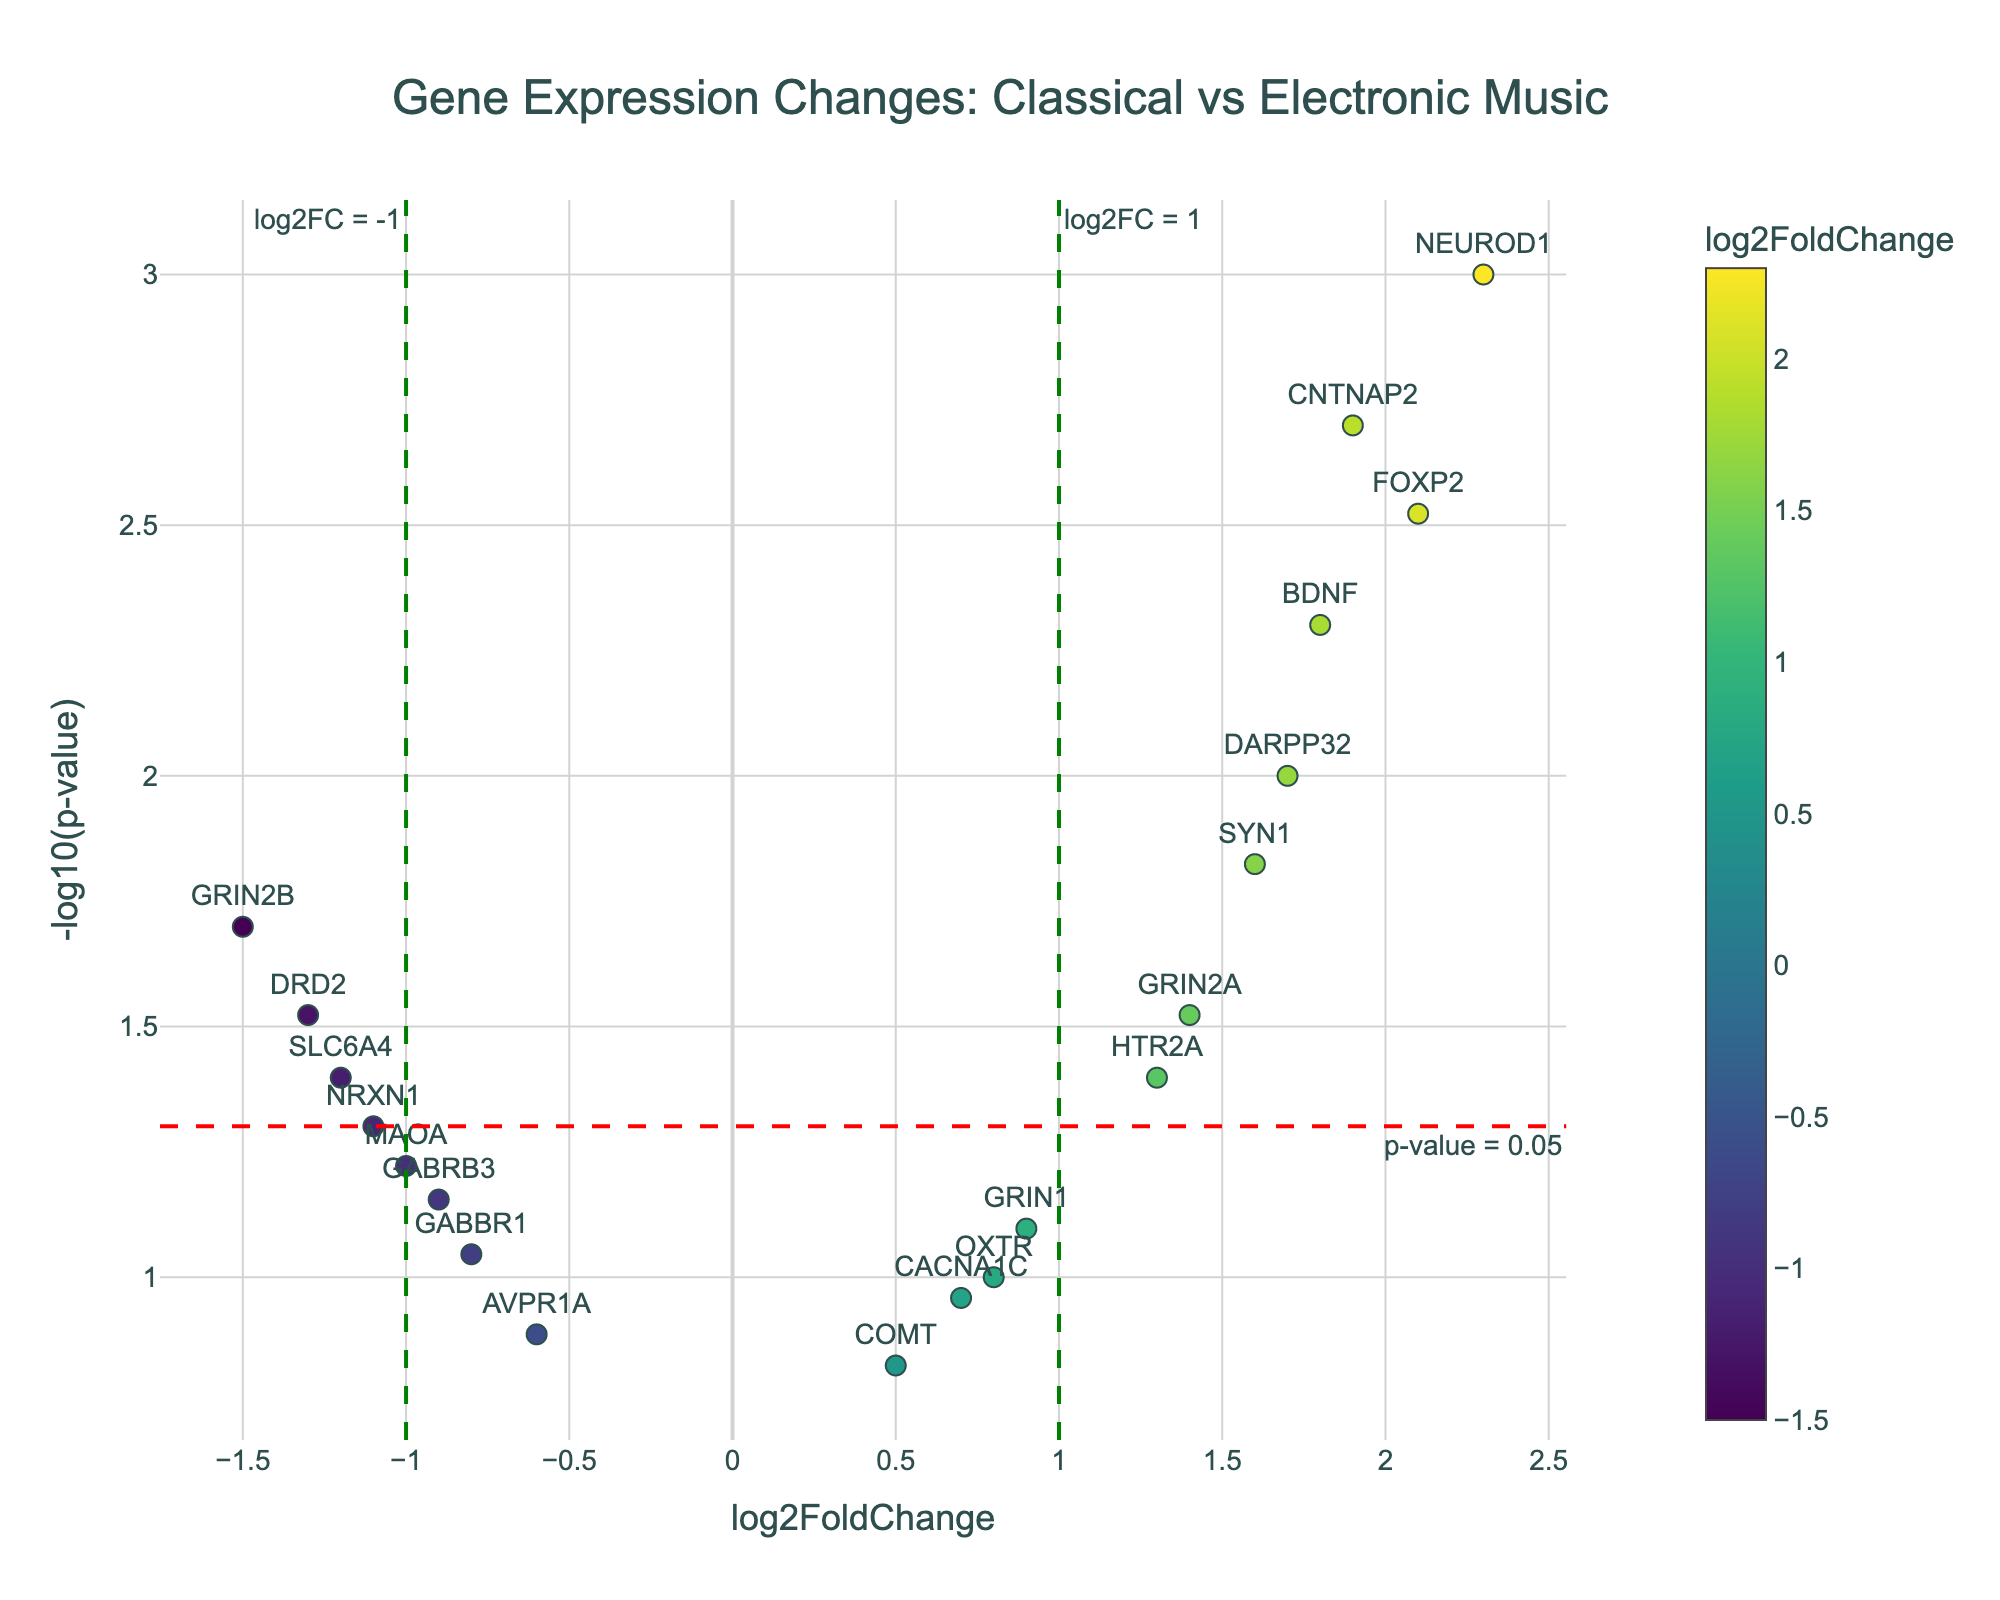Which gene shows the greatest log2FoldChange increase? To find the gene with the greatest log2FoldChange increase, look for the point with the highest x-value on the positive side of the horizontal axis. The gene NEUROD1 is at a log2FoldChange of 2.3, which is the highest.
Answer: NEUROD1 Which gene is the most statistically significant? The p-value indicates statistical significance, and smaller p-values are more significant. On a volcano plot, look for the point with the highest y-value. NEUROD1, with a -log10(p-value) around 3, is the most statistically significant.
Answer: NEUROD1 How many genes have a log2FoldChange greater than 1? Look for the data points to the right of the vertical line at log2FoldChange = 1. The genes are NEUROD1, BDNF, FOXP2, CNTNAP2, and DARPP32. Count these points to get the answer.
Answer: 5 Which gene has the smallest fold-change but still statistically significant (p-value < 0.05)? Focus on the points within the highlighted region below the horizontal line at -log10(0.05), then find the point closest to the vertical axis. SLC6A4, with a log2FoldChange of -1.2, is the smallest among the significant genes.
Answer: SLC6A4 Which two genes show similar levels of log2FoldChange but differ significantly in their p-values? Find points with similar x-coordinates but different y-coordinates. DARPP32 (log2FoldChange around 1.7, -log10(p-value) around 2) and GRIN2A (log2FoldChange around 1.4, -log10(p-value) around 1.5) fit this description.
Answer: DARPP32 and GRIN2A What is the log2FoldChange for the gene FOXP2, and is it statistically significant? Locate the point labeled FOXP2 and check its x and y values. FOXP2 has a log2FoldChange of 2.1 and a -log10(p-value) of about 2.5, indicating it is significant.
Answer: 2.1, Yes Do more genes have a positive or negative log2FoldChange? Count the points on the right (positive) and left (negative) sides of the vertical axis. There are more points on the positive side.
Answer: Positive How many genes have a p-value less than 0.001? Points above the horizontal line at -log10(0.001) are considered. NEUROD1 and CNTNAP2 are the genes. Count these points for the answer.
Answer: 2 